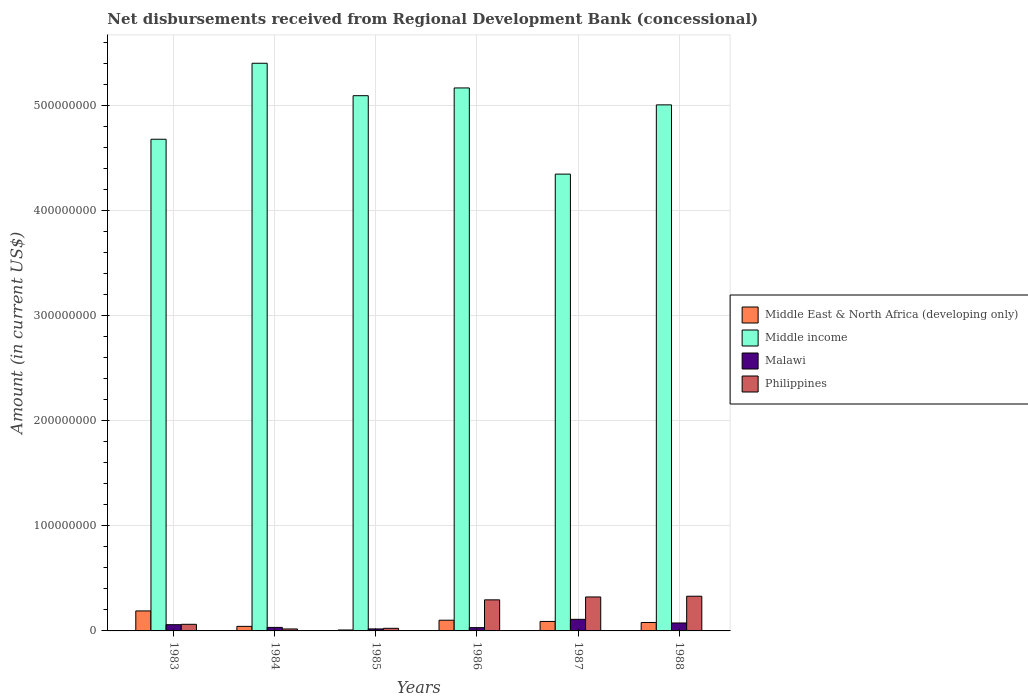How many groups of bars are there?
Ensure brevity in your answer.  6. What is the label of the 3rd group of bars from the left?
Give a very brief answer. 1985. What is the amount of disbursements received from Regional Development Bank in Middle income in 1985?
Your answer should be compact. 5.09e+08. Across all years, what is the maximum amount of disbursements received from Regional Development Bank in Philippines?
Provide a succinct answer. 3.30e+07. Across all years, what is the minimum amount of disbursements received from Regional Development Bank in Middle income?
Your response must be concise. 4.35e+08. In which year was the amount of disbursements received from Regional Development Bank in Philippines maximum?
Your answer should be compact. 1988. In which year was the amount of disbursements received from Regional Development Bank in Middle East & North Africa (developing only) minimum?
Ensure brevity in your answer.  1985. What is the total amount of disbursements received from Regional Development Bank in Philippines in the graph?
Offer a very short reply. 1.06e+08. What is the difference between the amount of disbursements received from Regional Development Bank in Malawi in 1985 and that in 1986?
Ensure brevity in your answer.  -1.22e+06. What is the difference between the amount of disbursements received from Regional Development Bank in Middle income in 1988 and the amount of disbursements received from Regional Development Bank in Middle East & North Africa (developing only) in 1985?
Keep it short and to the point. 5.00e+08. What is the average amount of disbursements received from Regional Development Bank in Philippines per year?
Offer a terse response. 1.76e+07. In the year 1984, what is the difference between the amount of disbursements received from Regional Development Bank in Malawi and amount of disbursements received from Regional Development Bank in Middle income?
Your answer should be very brief. -5.37e+08. What is the ratio of the amount of disbursements received from Regional Development Bank in Philippines in 1983 to that in 1988?
Make the answer very short. 0.19. Is the amount of disbursements received from Regional Development Bank in Middle income in 1983 less than that in 1988?
Offer a terse response. Yes. What is the difference between the highest and the second highest amount of disbursements received from Regional Development Bank in Middle East & North Africa (developing only)?
Keep it short and to the point. 8.83e+06. What is the difference between the highest and the lowest amount of disbursements received from Regional Development Bank in Philippines?
Your answer should be compact. 3.12e+07. In how many years, is the amount of disbursements received from Regional Development Bank in Malawi greater than the average amount of disbursements received from Regional Development Bank in Malawi taken over all years?
Keep it short and to the point. 3. Is the sum of the amount of disbursements received from Regional Development Bank in Malawi in 1984 and 1986 greater than the maximum amount of disbursements received from Regional Development Bank in Middle income across all years?
Ensure brevity in your answer.  No. Is it the case that in every year, the sum of the amount of disbursements received from Regional Development Bank in Philippines and amount of disbursements received from Regional Development Bank in Middle East & North Africa (developing only) is greater than the sum of amount of disbursements received from Regional Development Bank in Middle income and amount of disbursements received from Regional Development Bank in Malawi?
Your response must be concise. No. What does the 1st bar from the left in 1987 represents?
Your answer should be very brief. Middle East & North Africa (developing only). What does the 4th bar from the right in 1983 represents?
Ensure brevity in your answer.  Middle East & North Africa (developing only). Is it the case that in every year, the sum of the amount of disbursements received from Regional Development Bank in Middle income and amount of disbursements received from Regional Development Bank in Philippines is greater than the amount of disbursements received from Regional Development Bank in Malawi?
Your answer should be compact. Yes. Are all the bars in the graph horizontal?
Your response must be concise. No. How many years are there in the graph?
Make the answer very short. 6. What is the difference between two consecutive major ticks on the Y-axis?
Your answer should be compact. 1.00e+08. Are the values on the major ticks of Y-axis written in scientific E-notation?
Give a very brief answer. No. What is the title of the graph?
Ensure brevity in your answer.  Net disbursements received from Regional Development Bank (concessional). Does "Madagascar" appear as one of the legend labels in the graph?
Your answer should be very brief. No. What is the label or title of the Y-axis?
Your answer should be compact. Amount (in current US$). What is the Amount (in current US$) in Middle East & North Africa (developing only) in 1983?
Provide a short and direct response. 1.90e+07. What is the Amount (in current US$) of Middle income in 1983?
Give a very brief answer. 4.68e+08. What is the Amount (in current US$) in Malawi in 1983?
Provide a succinct answer. 5.93e+06. What is the Amount (in current US$) of Philippines in 1983?
Provide a succinct answer. 6.29e+06. What is the Amount (in current US$) of Middle East & North Africa (developing only) in 1984?
Offer a terse response. 4.33e+06. What is the Amount (in current US$) in Middle income in 1984?
Offer a terse response. 5.40e+08. What is the Amount (in current US$) in Malawi in 1984?
Your answer should be very brief. 3.35e+06. What is the Amount (in current US$) in Philippines in 1984?
Offer a terse response. 1.86e+06. What is the Amount (in current US$) in Middle East & North Africa (developing only) in 1985?
Your answer should be very brief. 8.91e+05. What is the Amount (in current US$) of Middle income in 1985?
Offer a very short reply. 5.09e+08. What is the Amount (in current US$) in Malawi in 1985?
Provide a succinct answer. 1.90e+06. What is the Amount (in current US$) in Philippines in 1985?
Offer a very short reply. 2.49e+06. What is the Amount (in current US$) of Middle East & North Africa (developing only) in 1986?
Provide a short and direct response. 1.02e+07. What is the Amount (in current US$) in Middle income in 1986?
Keep it short and to the point. 5.17e+08. What is the Amount (in current US$) in Malawi in 1986?
Ensure brevity in your answer.  3.12e+06. What is the Amount (in current US$) of Philippines in 1986?
Keep it short and to the point. 2.96e+07. What is the Amount (in current US$) of Middle East & North Africa (developing only) in 1987?
Make the answer very short. 9.02e+06. What is the Amount (in current US$) of Middle income in 1987?
Keep it short and to the point. 4.35e+08. What is the Amount (in current US$) in Malawi in 1987?
Ensure brevity in your answer.  1.10e+07. What is the Amount (in current US$) in Philippines in 1987?
Provide a succinct answer. 3.23e+07. What is the Amount (in current US$) of Middle East & North Africa (developing only) in 1988?
Make the answer very short. 8.03e+06. What is the Amount (in current US$) of Middle income in 1988?
Provide a short and direct response. 5.01e+08. What is the Amount (in current US$) in Malawi in 1988?
Provide a succinct answer. 7.56e+06. What is the Amount (in current US$) of Philippines in 1988?
Provide a succinct answer. 3.30e+07. Across all years, what is the maximum Amount (in current US$) of Middle East & North Africa (developing only)?
Offer a terse response. 1.90e+07. Across all years, what is the maximum Amount (in current US$) of Middle income?
Your answer should be very brief. 5.40e+08. Across all years, what is the maximum Amount (in current US$) of Malawi?
Make the answer very short. 1.10e+07. Across all years, what is the maximum Amount (in current US$) in Philippines?
Provide a short and direct response. 3.30e+07. Across all years, what is the minimum Amount (in current US$) in Middle East & North Africa (developing only)?
Make the answer very short. 8.91e+05. Across all years, what is the minimum Amount (in current US$) of Middle income?
Your response must be concise. 4.35e+08. Across all years, what is the minimum Amount (in current US$) in Malawi?
Provide a succinct answer. 1.90e+06. Across all years, what is the minimum Amount (in current US$) of Philippines?
Your answer should be very brief. 1.86e+06. What is the total Amount (in current US$) of Middle East & North Africa (developing only) in the graph?
Offer a very short reply. 5.15e+07. What is the total Amount (in current US$) in Middle income in the graph?
Offer a terse response. 2.97e+09. What is the total Amount (in current US$) of Malawi in the graph?
Your answer should be very brief. 3.29e+07. What is the total Amount (in current US$) in Philippines in the graph?
Your answer should be very brief. 1.06e+08. What is the difference between the Amount (in current US$) of Middle East & North Africa (developing only) in 1983 and that in 1984?
Provide a short and direct response. 1.47e+07. What is the difference between the Amount (in current US$) of Middle income in 1983 and that in 1984?
Provide a succinct answer. -7.23e+07. What is the difference between the Amount (in current US$) of Malawi in 1983 and that in 1984?
Give a very brief answer. 2.58e+06. What is the difference between the Amount (in current US$) of Philippines in 1983 and that in 1984?
Ensure brevity in your answer.  4.43e+06. What is the difference between the Amount (in current US$) of Middle East & North Africa (developing only) in 1983 and that in 1985?
Offer a terse response. 1.81e+07. What is the difference between the Amount (in current US$) of Middle income in 1983 and that in 1985?
Make the answer very short. -4.15e+07. What is the difference between the Amount (in current US$) in Malawi in 1983 and that in 1985?
Ensure brevity in your answer.  4.03e+06. What is the difference between the Amount (in current US$) of Philippines in 1983 and that in 1985?
Offer a very short reply. 3.80e+06. What is the difference between the Amount (in current US$) in Middle East & North Africa (developing only) in 1983 and that in 1986?
Your answer should be compact. 8.83e+06. What is the difference between the Amount (in current US$) of Middle income in 1983 and that in 1986?
Your response must be concise. -4.88e+07. What is the difference between the Amount (in current US$) in Malawi in 1983 and that in 1986?
Provide a short and direct response. 2.81e+06. What is the difference between the Amount (in current US$) of Philippines in 1983 and that in 1986?
Offer a terse response. -2.33e+07. What is the difference between the Amount (in current US$) in Middle East & North Africa (developing only) in 1983 and that in 1987?
Ensure brevity in your answer.  1.00e+07. What is the difference between the Amount (in current US$) of Middle income in 1983 and that in 1987?
Provide a short and direct response. 3.32e+07. What is the difference between the Amount (in current US$) in Malawi in 1983 and that in 1987?
Your response must be concise. -5.10e+06. What is the difference between the Amount (in current US$) in Philippines in 1983 and that in 1987?
Your answer should be very brief. -2.60e+07. What is the difference between the Amount (in current US$) of Middle East & North Africa (developing only) in 1983 and that in 1988?
Provide a succinct answer. 1.10e+07. What is the difference between the Amount (in current US$) of Middle income in 1983 and that in 1988?
Provide a short and direct response. -3.27e+07. What is the difference between the Amount (in current US$) of Malawi in 1983 and that in 1988?
Give a very brief answer. -1.63e+06. What is the difference between the Amount (in current US$) in Philippines in 1983 and that in 1988?
Give a very brief answer. -2.67e+07. What is the difference between the Amount (in current US$) of Middle East & North Africa (developing only) in 1984 and that in 1985?
Make the answer very short. 3.44e+06. What is the difference between the Amount (in current US$) of Middle income in 1984 and that in 1985?
Ensure brevity in your answer.  3.09e+07. What is the difference between the Amount (in current US$) in Malawi in 1984 and that in 1985?
Your answer should be very brief. 1.45e+06. What is the difference between the Amount (in current US$) in Philippines in 1984 and that in 1985?
Offer a very short reply. -6.29e+05. What is the difference between the Amount (in current US$) of Middle East & North Africa (developing only) in 1984 and that in 1986?
Provide a short and direct response. -5.86e+06. What is the difference between the Amount (in current US$) of Middle income in 1984 and that in 1986?
Ensure brevity in your answer.  2.35e+07. What is the difference between the Amount (in current US$) of Malawi in 1984 and that in 1986?
Give a very brief answer. 2.34e+05. What is the difference between the Amount (in current US$) of Philippines in 1984 and that in 1986?
Provide a short and direct response. -2.77e+07. What is the difference between the Amount (in current US$) in Middle East & North Africa (developing only) in 1984 and that in 1987?
Make the answer very short. -4.69e+06. What is the difference between the Amount (in current US$) of Middle income in 1984 and that in 1987?
Offer a very short reply. 1.06e+08. What is the difference between the Amount (in current US$) of Malawi in 1984 and that in 1987?
Your answer should be very brief. -7.67e+06. What is the difference between the Amount (in current US$) of Philippines in 1984 and that in 1987?
Your answer should be very brief. -3.05e+07. What is the difference between the Amount (in current US$) in Middle East & North Africa (developing only) in 1984 and that in 1988?
Provide a short and direct response. -3.70e+06. What is the difference between the Amount (in current US$) in Middle income in 1984 and that in 1988?
Your answer should be very brief. 3.96e+07. What is the difference between the Amount (in current US$) of Malawi in 1984 and that in 1988?
Your answer should be compact. -4.21e+06. What is the difference between the Amount (in current US$) of Philippines in 1984 and that in 1988?
Offer a very short reply. -3.12e+07. What is the difference between the Amount (in current US$) of Middle East & North Africa (developing only) in 1985 and that in 1986?
Make the answer very short. -9.30e+06. What is the difference between the Amount (in current US$) of Middle income in 1985 and that in 1986?
Your answer should be compact. -7.37e+06. What is the difference between the Amount (in current US$) of Malawi in 1985 and that in 1986?
Offer a very short reply. -1.22e+06. What is the difference between the Amount (in current US$) of Philippines in 1985 and that in 1986?
Your answer should be compact. -2.71e+07. What is the difference between the Amount (in current US$) in Middle East & North Africa (developing only) in 1985 and that in 1987?
Your answer should be compact. -8.13e+06. What is the difference between the Amount (in current US$) in Middle income in 1985 and that in 1987?
Your answer should be very brief. 7.46e+07. What is the difference between the Amount (in current US$) of Malawi in 1985 and that in 1987?
Provide a succinct answer. -9.13e+06. What is the difference between the Amount (in current US$) in Philippines in 1985 and that in 1987?
Give a very brief answer. -2.98e+07. What is the difference between the Amount (in current US$) of Middle East & North Africa (developing only) in 1985 and that in 1988?
Ensure brevity in your answer.  -7.14e+06. What is the difference between the Amount (in current US$) of Middle income in 1985 and that in 1988?
Offer a terse response. 8.73e+06. What is the difference between the Amount (in current US$) of Malawi in 1985 and that in 1988?
Your answer should be compact. -5.66e+06. What is the difference between the Amount (in current US$) of Philippines in 1985 and that in 1988?
Provide a succinct answer. -3.05e+07. What is the difference between the Amount (in current US$) of Middle East & North Africa (developing only) in 1986 and that in 1987?
Your response must be concise. 1.17e+06. What is the difference between the Amount (in current US$) of Middle income in 1986 and that in 1987?
Offer a very short reply. 8.20e+07. What is the difference between the Amount (in current US$) in Malawi in 1986 and that in 1987?
Provide a short and direct response. -7.91e+06. What is the difference between the Amount (in current US$) of Philippines in 1986 and that in 1987?
Your response must be concise. -2.76e+06. What is the difference between the Amount (in current US$) of Middle East & North Africa (developing only) in 1986 and that in 1988?
Your answer should be very brief. 2.16e+06. What is the difference between the Amount (in current US$) of Middle income in 1986 and that in 1988?
Your answer should be very brief. 1.61e+07. What is the difference between the Amount (in current US$) of Malawi in 1986 and that in 1988?
Offer a very short reply. -4.44e+06. What is the difference between the Amount (in current US$) of Philippines in 1986 and that in 1988?
Provide a short and direct response. -3.45e+06. What is the difference between the Amount (in current US$) of Middle East & North Africa (developing only) in 1987 and that in 1988?
Provide a short and direct response. 9.90e+05. What is the difference between the Amount (in current US$) in Middle income in 1987 and that in 1988?
Provide a short and direct response. -6.59e+07. What is the difference between the Amount (in current US$) in Malawi in 1987 and that in 1988?
Your answer should be compact. 3.47e+06. What is the difference between the Amount (in current US$) of Philippines in 1987 and that in 1988?
Keep it short and to the point. -6.99e+05. What is the difference between the Amount (in current US$) of Middle East & North Africa (developing only) in 1983 and the Amount (in current US$) of Middle income in 1984?
Your response must be concise. -5.21e+08. What is the difference between the Amount (in current US$) in Middle East & North Africa (developing only) in 1983 and the Amount (in current US$) in Malawi in 1984?
Give a very brief answer. 1.57e+07. What is the difference between the Amount (in current US$) in Middle East & North Africa (developing only) in 1983 and the Amount (in current US$) in Philippines in 1984?
Your answer should be compact. 1.72e+07. What is the difference between the Amount (in current US$) of Middle income in 1983 and the Amount (in current US$) of Malawi in 1984?
Offer a very short reply. 4.65e+08. What is the difference between the Amount (in current US$) in Middle income in 1983 and the Amount (in current US$) in Philippines in 1984?
Your answer should be very brief. 4.66e+08. What is the difference between the Amount (in current US$) in Malawi in 1983 and the Amount (in current US$) in Philippines in 1984?
Keep it short and to the point. 4.06e+06. What is the difference between the Amount (in current US$) in Middle East & North Africa (developing only) in 1983 and the Amount (in current US$) in Middle income in 1985?
Provide a succinct answer. -4.90e+08. What is the difference between the Amount (in current US$) in Middle East & North Africa (developing only) in 1983 and the Amount (in current US$) in Malawi in 1985?
Provide a succinct answer. 1.71e+07. What is the difference between the Amount (in current US$) in Middle East & North Africa (developing only) in 1983 and the Amount (in current US$) in Philippines in 1985?
Ensure brevity in your answer.  1.65e+07. What is the difference between the Amount (in current US$) of Middle income in 1983 and the Amount (in current US$) of Malawi in 1985?
Your answer should be very brief. 4.66e+08. What is the difference between the Amount (in current US$) in Middle income in 1983 and the Amount (in current US$) in Philippines in 1985?
Keep it short and to the point. 4.65e+08. What is the difference between the Amount (in current US$) of Malawi in 1983 and the Amount (in current US$) of Philippines in 1985?
Make the answer very short. 3.44e+06. What is the difference between the Amount (in current US$) in Middle East & North Africa (developing only) in 1983 and the Amount (in current US$) in Middle income in 1986?
Keep it short and to the point. -4.98e+08. What is the difference between the Amount (in current US$) of Middle East & North Africa (developing only) in 1983 and the Amount (in current US$) of Malawi in 1986?
Provide a succinct answer. 1.59e+07. What is the difference between the Amount (in current US$) in Middle East & North Africa (developing only) in 1983 and the Amount (in current US$) in Philippines in 1986?
Give a very brief answer. -1.05e+07. What is the difference between the Amount (in current US$) in Middle income in 1983 and the Amount (in current US$) in Malawi in 1986?
Your answer should be compact. 4.65e+08. What is the difference between the Amount (in current US$) of Middle income in 1983 and the Amount (in current US$) of Philippines in 1986?
Offer a terse response. 4.38e+08. What is the difference between the Amount (in current US$) of Malawi in 1983 and the Amount (in current US$) of Philippines in 1986?
Offer a terse response. -2.36e+07. What is the difference between the Amount (in current US$) of Middle East & North Africa (developing only) in 1983 and the Amount (in current US$) of Middle income in 1987?
Offer a very short reply. -4.16e+08. What is the difference between the Amount (in current US$) of Middle East & North Africa (developing only) in 1983 and the Amount (in current US$) of Malawi in 1987?
Give a very brief answer. 8.00e+06. What is the difference between the Amount (in current US$) of Middle East & North Africa (developing only) in 1983 and the Amount (in current US$) of Philippines in 1987?
Your response must be concise. -1.33e+07. What is the difference between the Amount (in current US$) in Middle income in 1983 and the Amount (in current US$) in Malawi in 1987?
Your response must be concise. 4.57e+08. What is the difference between the Amount (in current US$) in Middle income in 1983 and the Amount (in current US$) in Philippines in 1987?
Ensure brevity in your answer.  4.36e+08. What is the difference between the Amount (in current US$) of Malawi in 1983 and the Amount (in current US$) of Philippines in 1987?
Make the answer very short. -2.64e+07. What is the difference between the Amount (in current US$) of Middle East & North Africa (developing only) in 1983 and the Amount (in current US$) of Middle income in 1988?
Provide a short and direct response. -4.82e+08. What is the difference between the Amount (in current US$) of Middle East & North Africa (developing only) in 1983 and the Amount (in current US$) of Malawi in 1988?
Your answer should be compact. 1.15e+07. What is the difference between the Amount (in current US$) in Middle East & North Africa (developing only) in 1983 and the Amount (in current US$) in Philippines in 1988?
Offer a very short reply. -1.40e+07. What is the difference between the Amount (in current US$) in Middle income in 1983 and the Amount (in current US$) in Malawi in 1988?
Ensure brevity in your answer.  4.60e+08. What is the difference between the Amount (in current US$) of Middle income in 1983 and the Amount (in current US$) of Philippines in 1988?
Make the answer very short. 4.35e+08. What is the difference between the Amount (in current US$) of Malawi in 1983 and the Amount (in current US$) of Philippines in 1988?
Provide a short and direct response. -2.71e+07. What is the difference between the Amount (in current US$) of Middle East & North Africa (developing only) in 1984 and the Amount (in current US$) of Middle income in 1985?
Give a very brief answer. -5.05e+08. What is the difference between the Amount (in current US$) in Middle East & North Africa (developing only) in 1984 and the Amount (in current US$) in Malawi in 1985?
Offer a terse response. 2.43e+06. What is the difference between the Amount (in current US$) of Middle East & North Africa (developing only) in 1984 and the Amount (in current US$) of Philippines in 1985?
Offer a very short reply. 1.84e+06. What is the difference between the Amount (in current US$) of Middle income in 1984 and the Amount (in current US$) of Malawi in 1985?
Make the answer very short. 5.38e+08. What is the difference between the Amount (in current US$) in Middle income in 1984 and the Amount (in current US$) in Philippines in 1985?
Make the answer very short. 5.38e+08. What is the difference between the Amount (in current US$) of Malawi in 1984 and the Amount (in current US$) of Philippines in 1985?
Offer a very short reply. 8.60e+05. What is the difference between the Amount (in current US$) of Middle East & North Africa (developing only) in 1984 and the Amount (in current US$) of Middle income in 1986?
Make the answer very short. -5.12e+08. What is the difference between the Amount (in current US$) in Middle East & North Africa (developing only) in 1984 and the Amount (in current US$) in Malawi in 1986?
Provide a succinct answer. 1.21e+06. What is the difference between the Amount (in current US$) in Middle East & North Africa (developing only) in 1984 and the Amount (in current US$) in Philippines in 1986?
Keep it short and to the point. -2.52e+07. What is the difference between the Amount (in current US$) of Middle income in 1984 and the Amount (in current US$) of Malawi in 1986?
Your answer should be very brief. 5.37e+08. What is the difference between the Amount (in current US$) in Middle income in 1984 and the Amount (in current US$) in Philippines in 1986?
Make the answer very short. 5.11e+08. What is the difference between the Amount (in current US$) of Malawi in 1984 and the Amount (in current US$) of Philippines in 1986?
Keep it short and to the point. -2.62e+07. What is the difference between the Amount (in current US$) of Middle East & North Africa (developing only) in 1984 and the Amount (in current US$) of Middle income in 1987?
Your answer should be compact. -4.30e+08. What is the difference between the Amount (in current US$) in Middle East & North Africa (developing only) in 1984 and the Amount (in current US$) in Malawi in 1987?
Offer a terse response. -6.70e+06. What is the difference between the Amount (in current US$) in Middle East & North Africa (developing only) in 1984 and the Amount (in current US$) in Philippines in 1987?
Provide a short and direct response. -2.80e+07. What is the difference between the Amount (in current US$) in Middle income in 1984 and the Amount (in current US$) in Malawi in 1987?
Keep it short and to the point. 5.29e+08. What is the difference between the Amount (in current US$) in Middle income in 1984 and the Amount (in current US$) in Philippines in 1987?
Keep it short and to the point. 5.08e+08. What is the difference between the Amount (in current US$) in Malawi in 1984 and the Amount (in current US$) in Philippines in 1987?
Your answer should be very brief. -2.90e+07. What is the difference between the Amount (in current US$) of Middle East & North Africa (developing only) in 1984 and the Amount (in current US$) of Middle income in 1988?
Make the answer very short. -4.96e+08. What is the difference between the Amount (in current US$) of Middle East & North Africa (developing only) in 1984 and the Amount (in current US$) of Malawi in 1988?
Keep it short and to the point. -3.23e+06. What is the difference between the Amount (in current US$) in Middle East & North Africa (developing only) in 1984 and the Amount (in current US$) in Philippines in 1988?
Your response must be concise. -2.87e+07. What is the difference between the Amount (in current US$) of Middle income in 1984 and the Amount (in current US$) of Malawi in 1988?
Provide a short and direct response. 5.33e+08. What is the difference between the Amount (in current US$) of Middle income in 1984 and the Amount (in current US$) of Philippines in 1988?
Ensure brevity in your answer.  5.07e+08. What is the difference between the Amount (in current US$) in Malawi in 1984 and the Amount (in current US$) in Philippines in 1988?
Provide a succinct answer. -2.97e+07. What is the difference between the Amount (in current US$) of Middle East & North Africa (developing only) in 1985 and the Amount (in current US$) of Middle income in 1986?
Provide a succinct answer. -5.16e+08. What is the difference between the Amount (in current US$) in Middle East & North Africa (developing only) in 1985 and the Amount (in current US$) in Malawi in 1986?
Provide a succinct answer. -2.23e+06. What is the difference between the Amount (in current US$) of Middle East & North Africa (developing only) in 1985 and the Amount (in current US$) of Philippines in 1986?
Provide a succinct answer. -2.87e+07. What is the difference between the Amount (in current US$) in Middle income in 1985 and the Amount (in current US$) in Malawi in 1986?
Your answer should be very brief. 5.06e+08. What is the difference between the Amount (in current US$) in Middle income in 1985 and the Amount (in current US$) in Philippines in 1986?
Provide a succinct answer. 4.80e+08. What is the difference between the Amount (in current US$) in Malawi in 1985 and the Amount (in current US$) in Philippines in 1986?
Provide a short and direct response. -2.77e+07. What is the difference between the Amount (in current US$) in Middle East & North Africa (developing only) in 1985 and the Amount (in current US$) in Middle income in 1987?
Give a very brief answer. -4.34e+08. What is the difference between the Amount (in current US$) of Middle East & North Africa (developing only) in 1985 and the Amount (in current US$) of Malawi in 1987?
Ensure brevity in your answer.  -1.01e+07. What is the difference between the Amount (in current US$) of Middle East & North Africa (developing only) in 1985 and the Amount (in current US$) of Philippines in 1987?
Ensure brevity in your answer.  -3.14e+07. What is the difference between the Amount (in current US$) in Middle income in 1985 and the Amount (in current US$) in Malawi in 1987?
Give a very brief answer. 4.98e+08. What is the difference between the Amount (in current US$) of Middle income in 1985 and the Amount (in current US$) of Philippines in 1987?
Provide a succinct answer. 4.77e+08. What is the difference between the Amount (in current US$) in Malawi in 1985 and the Amount (in current US$) in Philippines in 1987?
Your answer should be compact. -3.04e+07. What is the difference between the Amount (in current US$) in Middle East & North Africa (developing only) in 1985 and the Amount (in current US$) in Middle income in 1988?
Your response must be concise. -5.00e+08. What is the difference between the Amount (in current US$) in Middle East & North Africa (developing only) in 1985 and the Amount (in current US$) in Malawi in 1988?
Give a very brief answer. -6.67e+06. What is the difference between the Amount (in current US$) of Middle East & North Africa (developing only) in 1985 and the Amount (in current US$) of Philippines in 1988?
Ensure brevity in your answer.  -3.21e+07. What is the difference between the Amount (in current US$) of Middle income in 1985 and the Amount (in current US$) of Malawi in 1988?
Provide a succinct answer. 5.02e+08. What is the difference between the Amount (in current US$) in Middle income in 1985 and the Amount (in current US$) in Philippines in 1988?
Your answer should be very brief. 4.76e+08. What is the difference between the Amount (in current US$) of Malawi in 1985 and the Amount (in current US$) of Philippines in 1988?
Provide a short and direct response. -3.11e+07. What is the difference between the Amount (in current US$) in Middle East & North Africa (developing only) in 1986 and the Amount (in current US$) in Middle income in 1987?
Make the answer very short. -4.25e+08. What is the difference between the Amount (in current US$) in Middle East & North Africa (developing only) in 1986 and the Amount (in current US$) in Malawi in 1987?
Your response must be concise. -8.34e+05. What is the difference between the Amount (in current US$) of Middle East & North Africa (developing only) in 1986 and the Amount (in current US$) of Philippines in 1987?
Your answer should be compact. -2.21e+07. What is the difference between the Amount (in current US$) in Middle income in 1986 and the Amount (in current US$) in Malawi in 1987?
Give a very brief answer. 5.06e+08. What is the difference between the Amount (in current US$) in Middle income in 1986 and the Amount (in current US$) in Philippines in 1987?
Your answer should be compact. 4.84e+08. What is the difference between the Amount (in current US$) in Malawi in 1986 and the Amount (in current US$) in Philippines in 1987?
Ensure brevity in your answer.  -2.92e+07. What is the difference between the Amount (in current US$) of Middle East & North Africa (developing only) in 1986 and the Amount (in current US$) of Middle income in 1988?
Keep it short and to the point. -4.91e+08. What is the difference between the Amount (in current US$) in Middle East & North Africa (developing only) in 1986 and the Amount (in current US$) in Malawi in 1988?
Keep it short and to the point. 2.63e+06. What is the difference between the Amount (in current US$) in Middle East & North Africa (developing only) in 1986 and the Amount (in current US$) in Philippines in 1988?
Provide a succinct answer. -2.28e+07. What is the difference between the Amount (in current US$) in Middle income in 1986 and the Amount (in current US$) in Malawi in 1988?
Provide a short and direct response. 5.09e+08. What is the difference between the Amount (in current US$) of Middle income in 1986 and the Amount (in current US$) of Philippines in 1988?
Give a very brief answer. 4.84e+08. What is the difference between the Amount (in current US$) in Malawi in 1986 and the Amount (in current US$) in Philippines in 1988?
Make the answer very short. -2.99e+07. What is the difference between the Amount (in current US$) of Middle East & North Africa (developing only) in 1987 and the Amount (in current US$) of Middle income in 1988?
Give a very brief answer. -4.92e+08. What is the difference between the Amount (in current US$) of Middle East & North Africa (developing only) in 1987 and the Amount (in current US$) of Malawi in 1988?
Your answer should be compact. 1.46e+06. What is the difference between the Amount (in current US$) in Middle East & North Africa (developing only) in 1987 and the Amount (in current US$) in Philippines in 1988?
Offer a terse response. -2.40e+07. What is the difference between the Amount (in current US$) of Middle income in 1987 and the Amount (in current US$) of Malawi in 1988?
Keep it short and to the point. 4.27e+08. What is the difference between the Amount (in current US$) in Middle income in 1987 and the Amount (in current US$) in Philippines in 1988?
Your answer should be compact. 4.02e+08. What is the difference between the Amount (in current US$) of Malawi in 1987 and the Amount (in current US$) of Philippines in 1988?
Ensure brevity in your answer.  -2.20e+07. What is the average Amount (in current US$) of Middle East & North Africa (developing only) per year?
Make the answer very short. 8.58e+06. What is the average Amount (in current US$) of Middle income per year?
Your response must be concise. 4.95e+08. What is the average Amount (in current US$) in Malawi per year?
Your answer should be compact. 5.48e+06. What is the average Amount (in current US$) in Philippines per year?
Keep it short and to the point. 1.76e+07. In the year 1983, what is the difference between the Amount (in current US$) of Middle East & North Africa (developing only) and Amount (in current US$) of Middle income?
Keep it short and to the point. -4.49e+08. In the year 1983, what is the difference between the Amount (in current US$) of Middle East & North Africa (developing only) and Amount (in current US$) of Malawi?
Your response must be concise. 1.31e+07. In the year 1983, what is the difference between the Amount (in current US$) in Middle East & North Africa (developing only) and Amount (in current US$) in Philippines?
Offer a terse response. 1.27e+07. In the year 1983, what is the difference between the Amount (in current US$) of Middle income and Amount (in current US$) of Malawi?
Provide a succinct answer. 4.62e+08. In the year 1983, what is the difference between the Amount (in current US$) in Middle income and Amount (in current US$) in Philippines?
Provide a short and direct response. 4.62e+08. In the year 1983, what is the difference between the Amount (in current US$) of Malawi and Amount (in current US$) of Philippines?
Offer a terse response. -3.61e+05. In the year 1984, what is the difference between the Amount (in current US$) of Middle East & North Africa (developing only) and Amount (in current US$) of Middle income?
Your response must be concise. -5.36e+08. In the year 1984, what is the difference between the Amount (in current US$) of Middle East & North Africa (developing only) and Amount (in current US$) of Malawi?
Your answer should be very brief. 9.75e+05. In the year 1984, what is the difference between the Amount (in current US$) in Middle East & North Africa (developing only) and Amount (in current US$) in Philippines?
Provide a short and direct response. 2.46e+06. In the year 1984, what is the difference between the Amount (in current US$) of Middle income and Amount (in current US$) of Malawi?
Give a very brief answer. 5.37e+08. In the year 1984, what is the difference between the Amount (in current US$) in Middle income and Amount (in current US$) in Philippines?
Give a very brief answer. 5.38e+08. In the year 1984, what is the difference between the Amount (in current US$) of Malawi and Amount (in current US$) of Philippines?
Offer a very short reply. 1.49e+06. In the year 1985, what is the difference between the Amount (in current US$) of Middle East & North Africa (developing only) and Amount (in current US$) of Middle income?
Your response must be concise. -5.09e+08. In the year 1985, what is the difference between the Amount (in current US$) in Middle East & North Africa (developing only) and Amount (in current US$) in Malawi?
Ensure brevity in your answer.  -1.01e+06. In the year 1985, what is the difference between the Amount (in current US$) of Middle East & North Africa (developing only) and Amount (in current US$) of Philippines?
Provide a short and direct response. -1.60e+06. In the year 1985, what is the difference between the Amount (in current US$) of Middle income and Amount (in current US$) of Malawi?
Provide a short and direct response. 5.08e+08. In the year 1985, what is the difference between the Amount (in current US$) in Middle income and Amount (in current US$) in Philippines?
Ensure brevity in your answer.  5.07e+08. In the year 1985, what is the difference between the Amount (in current US$) of Malawi and Amount (in current US$) of Philippines?
Make the answer very short. -5.94e+05. In the year 1986, what is the difference between the Amount (in current US$) of Middle East & North Africa (developing only) and Amount (in current US$) of Middle income?
Offer a very short reply. -5.07e+08. In the year 1986, what is the difference between the Amount (in current US$) in Middle East & North Africa (developing only) and Amount (in current US$) in Malawi?
Offer a very short reply. 7.07e+06. In the year 1986, what is the difference between the Amount (in current US$) of Middle East & North Africa (developing only) and Amount (in current US$) of Philippines?
Give a very brief answer. -1.94e+07. In the year 1986, what is the difference between the Amount (in current US$) of Middle income and Amount (in current US$) of Malawi?
Provide a short and direct response. 5.14e+08. In the year 1986, what is the difference between the Amount (in current US$) in Middle income and Amount (in current US$) in Philippines?
Your answer should be compact. 4.87e+08. In the year 1986, what is the difference between the Amount (in current US$) in Malawi and Amount (in current US$) in Philippines?
Your answer should be compact. -2.65e+07. In the year 1987, what is the difference between the Amount (in current US$) in Middle East & North Africa (developing only) and Amount (in current US$) in Middle income?
Offer a very short reply. -4.26e+08. In the year 1987, what is the difference between the Amount (in current US$) of Middle East & North Africa (developing only) and Amount (in current US$) of Malawi?
Provide a short and direct response. -2.01e+06. In the year 1987, what is the difference between the Amount (in current US$) in Middle East & North Africa (developing only) and Amount (in current US$) in Philippines?
Provide a short and direct response. -2.33e+07. In the year 1987, what is the difference between the Amount (in current US$) in Middle income and Amount (in current US$) in Malawi?
Your response must be concise. 4.24e+08. In the year 1987, what is the difference between the Amount (in current US$) of Middle income and Amount (in current US$) of Philippines?
Your answer should be compact. 4.02e+08. In the year 1987, what is the difference between the Amount (in current US$) in Malawi and Amount (in current US$) in Philippines?
Ensure brevity in your answer.  -2.13e+07. In the year 1988, what is the difference between the Amount (in current US$) of Middle East & North Africa (developing only) and Amount (in current US$) of Middle income?
Your answer should be very brief. -4.93e+08. In the year 1988, what is the difference between the Amount (in current US$) in Middle East & North Africa (developing only) and Amount (in current US$) in Malawi?
Your response must be concise. 4.69e+05. In the year 1988, what is the difference between the Amount (in current US$) of Middle East & North Africa (developing only) and Amount (in current US$) of Philippines?
Give a very brief answer. -2.50e+07. In the year 1988, what is the difference between the Amount (in current US$) of Middle income and Amount (in current US$) of Malawi?
Provide a short and direct response. 4.93e+08. In the year 1988, what is the difference between the Amount (in current US$) in Middle income and Amount (in current US$) in Philippines?
Keep it short and to the point. 4.68e+08. In the year 1988, what is the difference between the Amount (in current US$) in Malawi and Amount (in current US$) in Philippines?
Offer a very short reply. -2.55e+07. What is the ratio of the Amount (in current US$) of Middle East & North Africa (developing only) in 1983 to that in 1984?
Your response must be concise. 4.39. What is the ratio of the Amount (in current US$) in Middle income in 1983 to that in 1984?
Ensure brevity in your answer.  0.87. What is the ratio of the Amount (in current US$) in Malawi in 1983 to that in 1984?
Your answer should be very brief. 1.77. What is the ratio of the Amount (in current US$) of Philippines in 1983 to that in 1984?
Offer a very short reply. 3.37. What is the ratio of the Amount (in current US$) in Middle East & North Africa (developing only) in 1983 to that in 1985?
Keep it short and to the point. 21.35. What is the ratio of the Amount (in current US$) in Middle income in 1983 to that in 1985?
Your answer should be compact. 0.92. What is the ratio of the Amount (in current US$) in Malawi in 1983 to that in 1985?
Make the answer very short. 3.12. What is the ratio of the Amount (in current US$) in Philippines in 1983 to that in 1985?
Provide a short and direct response. 2.52. What is the ratio of the Amount (in current US$) of Middle East & North Africa (developing only) in 1983 to that in 1986?
Ensure brevity in your answer.  1.87. What is the ratio of the Amount (in current US$) of Middle income in 1983 to that in 1986?
Offer a terse response. 0.91. What is the ratio of the Amount (in current US$) in Malawi in 1983 to that in 1986?
Your answer should be very brief. 1.9. What is the ratio of the Amount (in current US$) in Philippines in 1983 to that in 1986?
Your answer should be compact. 0.21. What is the ratio of the Amount (in current US$) of Middle East & North Africa (developing only) in 1983 to that in 1987?
Offer a terse response. 2.11. What is the ratio of the Amount (in current US$) in Middle income in 1983 to that in 1987?
Ensure brevity in your answer.  1.08. What is the ratio of the Amount (in current US$) of Malawi in 1983 to that in 1987?
Provide a short and direct response. 0.54. What is the ratio of the Amount (in current US$) in Philippines in 1983 to that in 1987?
Give a very brief answer. 0.19. What is the ratio of the Amount (in current US$) of Middle East & North Africa (developing only) in 1983 to that in 1988?
Offer a very short reply. 2.37. What is the ratio of the Amount (in current US$) of Middle income in 1983 to that in 1988?
Offer a terse response. 0.93. What is the ratio of the Amount (in current US$) in Malawi in 1983 to that in 1988?
Your answer should be very brief. 0.78. What is the ratio of the Amount (in current US$) in Philippines in 1983 to that in 1988?
Your response must be concise. 0.19. What is the ratio of the Amount (in current US$) of Middle East & North Africa (developing only) in 1984 to that in 1985?
Provide a succinct answer. 4.86. What is the ratio of the Amount (in current US$) of Middle income in 1984 to that in 1985?
Give a very brief answer. 1.06. What is the ratio of the Amount (in current US$) of Malawi in 1984 to that in 1985?
Offer a terse response. 1.77. What is the ratio of the Amount (in current US$) in Philippines in 1984 to that in 1985?
Ensure brevity in your answer.  0.75. What is the ratio of the Amount (in current US$) in Middle East & North Africa (developing only) in 1984 to that in 1986?
Your answer should be very brief. 0.42. What is the ratio of the Amount (in current US$) of Middle income in 1984 to that in 1986?
Offer a terse response. 1.05. What is the ratio of the Amount (in current US$) of Malawi in 1984 to that in 1986?
Offer a terse response. 1.07. What is the ratio of the Amount (in current US$) in Philippines in 1984 to that in 1986?
Your answer should be compact. 0.06. What is the ratio of the Amount (in current US$) of Middle East & North Africa (developing only) in 1984 to that in 1987?
Ensure brevity in your answer.  0.48. What is the ratio of the Amount (in current US$) of Middle income in 1984 to that in 1987?
Ensure brevity in your answer.  1.24. What is the ratio of the Amount (in current US$) in Malawi in 1984 to that in 1987?
Give a very brief answer. 0.3. What is the ratio of the Amount (in current US$) in Philippines in 1984 to that in 1987?
Your answer should be very brief. 0.06. What is the ratio of the Amount (in current US$) in Middle East & North Africa (developing only) in 1984 to that in 1988?
Offer a very short reply. 0.54. What is the ratio of the Amount (in current US$) of Middle income in 1984 to that in 1988?
Provide a succinct answer. 1.08. What is the ratio of the Amount (in current US$) in Malawi in 1984 to that in 1988?
Offer a very short reply. 0.44. What is the ratio of the Amount (in current US$) in Philippines in 1984 to that in 1988?
Make the answer very short. 0.06. What is the ratio of the Amount (in current US$) of Middle East & North Africa (developing only) in 1985 to that in 1986?
Your response must be concise. 0.09. What is the ratio of the Amount (in current US$) of Middle income in 1985 to that in 1986?
Your answer should be compact. 0.99. What is the ratio of the Amount (in current US$) in Malawi in 1985 to that in 1986?
Provide a succinct answer. 0.61. What is the ratio of the Amount (in current US$) of Philippines in 1985 to that in 1986?
Offer a terse response. 0.08. What is the ratio of the Amount (in current US$) of Middle East & North Africa (developing only) in 1985 to that in 1987?
Your answer should be compact. 0.1. What is the ratio of the Amount (in current US$) in Middle income in 1985 to that in 1987?
Offer a terse response. 1.17. What is the ratio of the Amount (in current US$) in Malawi in 1985 to that in 1987?
Provide a short and direct response. 0.17. What is the ratio of the Amount (in current US$) of Philippines in 1985 to that in 1987?
Provide a short and direct response. 0.08. What is the ratio of the Amount (in current US$) in Middle East & North Africa (developing only) in 1985 to that in 1988?
Your response must be concise. 0.11. What is the ratio of the Amount (in current US$) in Middle income in 1985 to that in 1988?
Your response must be concise. 1.02. What is the ratio of the Amount (in current US$) in Malawi in 1985 to that in 1988?
Make the answer very short. 0.25. What is the ratio of the Amount (in current US$) of Philippines in 1985 to that in 1988?
Your response must be concise. 0.08. What is the ratio of the Amount (in current US$) of Middle East & North Africa (developing only) in 1986 to that in 1987?
Provide a short and direct response. 1.13. What is the ratio of the Amount (in current US$) in Middle income in 1986 to that in 1987?
Provide a succinct answer. 1.19. What is the ratio of the Amount (in current US$) of Malawi in 1986 to that in 1987?
Make the answer very short. 0.28. What is the ratio of the Amount (in current US$) in Philippines in 1986 to that in 1987?
Make the answer very short. 0.91. What is the ratio of the Amount (in current US$) of Middle East & North Africa (developing only) in 1986 to that in 1988?
Your answer should be compact. 1.27. What is the ratio of the Amount (in current US$) in Middle income in 1986 to that in 1988?
Give a very brief answer. 1.03. What is the ratio of the Amount (in current US$) in Malawi in 1986 to that in 1988?
Ensure brevity in your answer.  0.41. What is the ratio of the Amount (in current US$) in Philippines in 1986 to that in 1988?
Your answer should be very brief. 0.9. What is the ratio of the Amount (in current US$) of Middle East & North Africa (developing only) in 1987 to that in 1988?
Your response must be concise. 1.12. What is the ratio of the Amount (in current US$) in Middle income in 1987 to that in 1988?
Ensure brevity in your answer.  0.87. What is the ratio of the Amount (in current US$) in Malawi in 1987 to that in 1988?
Keep it short and to the point. 1.46. What is the ratio of the Amount (in current US$) of Philippines in 1987 to that in 1988?
Provide a short and direct response. 0.98. What is the difference between the highest and the second highest Amount (in current US$) in Middle East & North Africa (developing only)?
Your answer should be very brief. 8.83e+06. What is the difference between the highest and the second highest Amount (in current US$) of Middle income?
Offer a terse response. 2.35e+07. What is the difference between the highest and the second highest Amount (in current US$) in Malawi?
Your response must be concise. 3.47e+06. What is the difference between the highest and the second highest Amount (in current US$) in Philippines?
Your answer should be compact. 6.99e+05. What is the difference between the highest and the lowest Amount (in current US$) in Middle East & North Africa (developing only)?
Give a very brief answer. 1.81e+07. What is the difference between the highest and the lowest Amount (in current US$) in Middle income?
Your answer should be very brief. 1.06e+08. What is the difference between the highest and the lowest Amount (in current US$) in Malawi?
Offer a terse response. 9.13e+06. What is the difference between the highest and the lowest Amount (in current US$) in Philippines?
Your answer should be compact. 3.12e+07. 